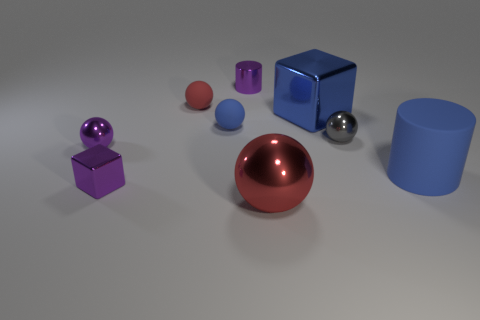What number of rubber things are large red balls or big blue cylinders?
Your answer should be compact. 1. Are there any other shiny spheres that have the same size as the purple metallic sphere?
Your response must be concise. Yes. What shape is the big object that is the same color as the large rubber cylinder?
Offer a very short reply. Cube. How many red metallic objects are the same size as the shiny cylinder?
Ensure brevity in your answer.  0. Is the size of the matte object to the right of the tiny blue thing the same as the shiny block that is in front of the large cylinder?
Make the answer very short. No. How many objects are small red shiny cylinders or shiny cubes behind the big cylinder?
Keep it short and to the point. 1. The tiny shiny cube is what color?
Your answer should be very brief. Purple. What material is the red object behind the large cylinder right of the small cylinder on the left side of the big red shiny object?
Your answer should be very brief. Rubber. What size is the red thing that is made of the same material as the tiny purple ball?
Offer a terse response. Large. Are there any objects that have the same color as the large ball?
Your answer should be compact. Yes. 